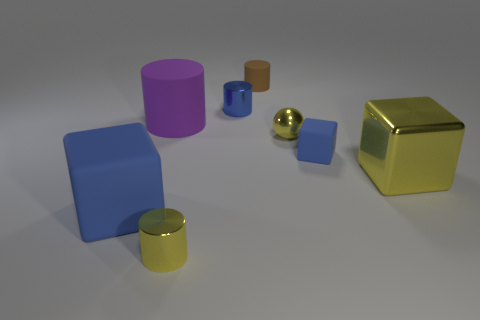How many blue blocks must be subtracted to get 1 blue blocks? 1 Subtract all tiny blue metal cylinders. How many cylinders are left? 3 Subtract all red cylinders. How many blue cubes are left? 2 Add 1 large purple cylinders. How many objects exist? 9 Subtract all yellow cylinders. How many cylinders are left? 3 Subtract 2 cylinders. How many cylinders are left? 2 Subtract all blocks. How many objects are left? 5 Add 7 large yellow metallic things. How many large yellow metallic things are left? 8 Add 4 tiny red blocks. How many tiny red blocks exist? 4 Subtract 0 purple balls. How many objects are left? 8 